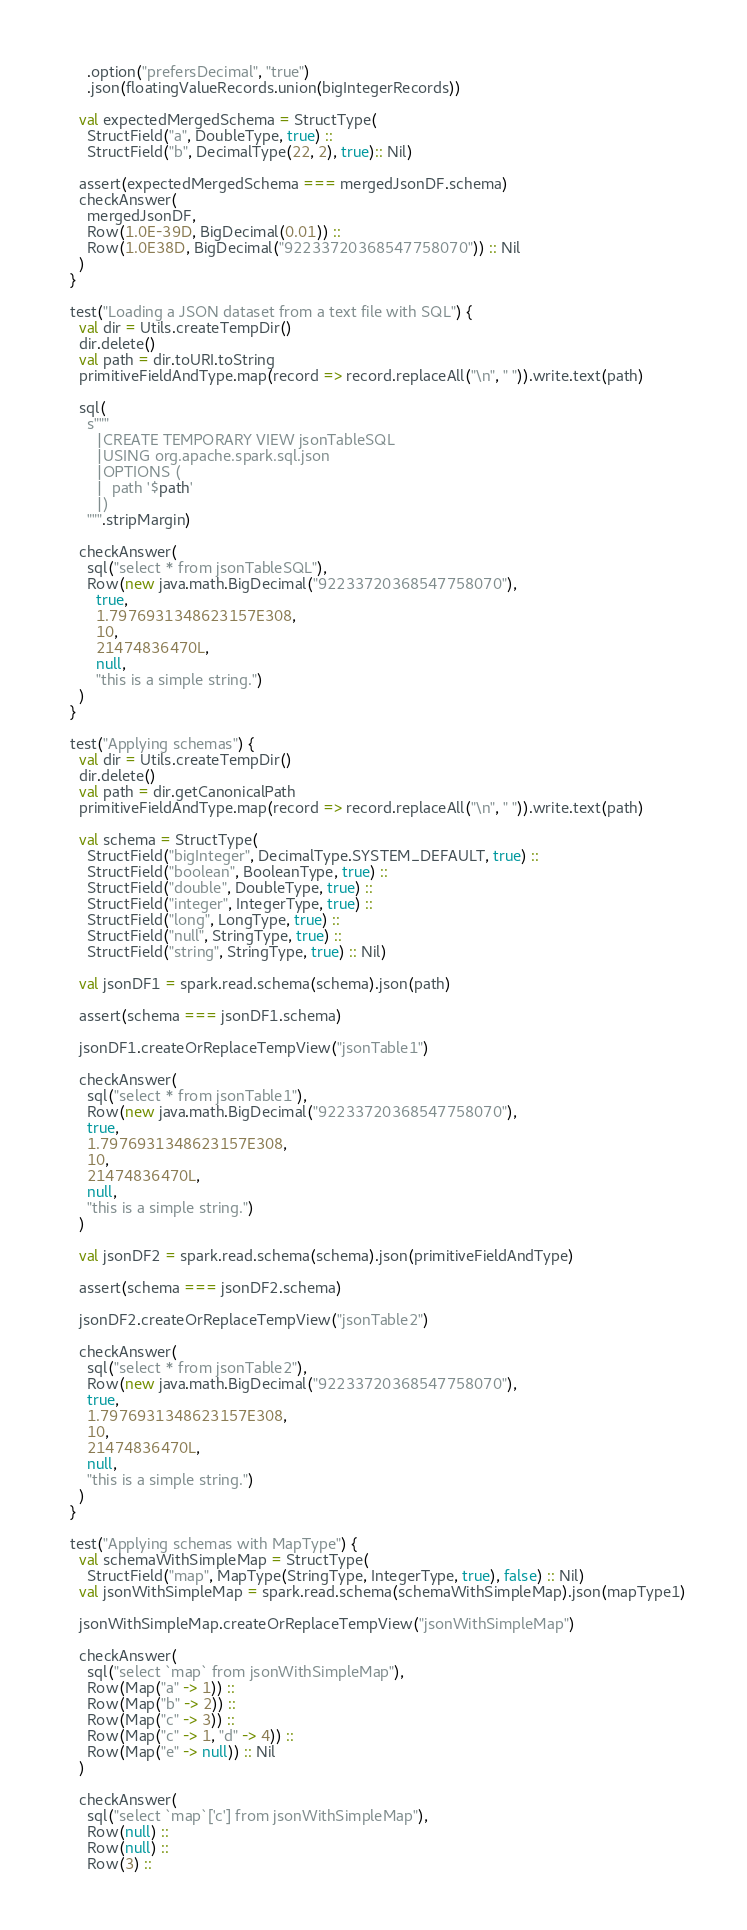Convert code to text. <code><loc_0><loc_0><loc_500><loc_500><_Scala_>      .option("prefersDecimal", "true")
      .json(floatingValueRecords.union(bigIntegerRecords))

    val expectedMergedSchema = StructType(
      StructField("a", DoubleType, true) ::
      StructField("b", DecimalType(22, 2), true):: Nil)

    assert(expectedMergedSchema === mergedJsonDF.schema)
    checkAnswer(
      mergedJsonDF,
      Row(1.0E-39D, BigDecimal(0.01)) ::
      Row(1.0E38D, BigDecimal("92233720368547758070")) :: Nil
    )
  }

  test("Loading a JSON dataset from a text file with SQL") {
    val dir = Utils.createTempDir()
    dir.delete()
    val path = dir.toURI.toString
    primitiveFieldAndType.map(record => record.replaceAll("\n", " ")).write.text(path)

    sql(
      s"""
        |CREATE TEMPORARY VIEW jsonTableSQL
        |USING org.apache.spark.sql.json
        |OPTIONS (
        |  path '$path'
        |)
      """.stripMargin)

    checkAnswer(
      sql("select * from jsonTableSQL"),
      Row(new java.math.BigDecimal("92233720368547758070"),
        true,
        1.7976931348623157E308,
        10,
        21474836470L,
        null,
        "this is a simple string.")
    )
  }

  test("Applying schemas") {
    val dir = Utils.createTempDir()
    dir.delete()
    val path = dir.getCanonicalPath
    primitiveFieldAndType.map(record => record.replaceAll("\n", " ")).write.text(path)

    val schema = StructType(
      StructField("bigInteger", DecimalType.SYSTEM_DEFAULT, true) ::
      StructField("boolean", BooleanType, true) ::
      StructField("double", DoubleType, true) ::
      StructField("integer", IntegerType, true) ::
      StructField("long", LongType, true) ::
      StructField("null", StringType, true) ::
      StructField("string", StringType, true) :: Nil)

    val jsonDF1 = spark.read.schema(schema).json(path)

    assert(schema === jsonDF1.schema)

    jsonDF1.createOrReplaceTempView("jsonTable1")

    checkAnswer(
      sql("select * from jsonTable1"),
      Row(new java.math.BigDecimal("92233720368547758070"),
      true,
      1.7976931348623157E308,
      10,
      21474836470L,
      null,
      "this is a simple string.")
    )

    val jsonDF2 = spark.read.schema(schema).json(primitiveFieldAndType)

    assert(schema === jsonDF2.schema)

    jsonDF2.createOrReplaceTempView("jsonTable2")

    checkAnswer(
      sql("select * from jsonTable2"),
      Row(new java.math.BigDecimal("92233720368547758070"),
      true,
      1.7976931348623157E308,
      10,
      21474836470L,
      null,
      "this is a simple string.")
    )
  }

  test("Applying schemas with MapType") {
    val schemaWithSimpleMap = StructType(
      StructField("map", MapType(StringType, IntegerType, true), false) :: Nil)
    val jsonWithSimpleMap = spark.read.schema(schemaWithSimpleMap).json(mapType1)

    jsonWithSimpleMap.createOrReplaceTempView("jsonWithSimpleMap")

    checkAnswer(
      sql("select `map` from jsonWithSimpleMap"),
      Row(Map("a" -> 1)) ::
      Row(Map("b" -> 2)) ::
      Row(Map("c" -> 3)) ::
      Row(Map("c" -> 1, "d" -> 4)) ::
      Row(Map("e" -> null)) :: Nil
    )

    checkAnswer(
      sql("select `map`['c'] from jsonWithSimpleMap"),
      Row(null) ::
      Row(null) ::
      Row(3) ::</code> 